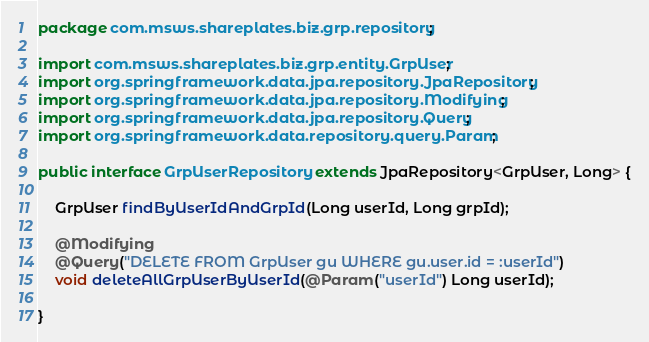<code> <loc_0><loc_0><loc_500><loc_500><_Java_>package com.msws.shareplates.biz.grp.repository;

import com.msws.shareplates.biz.grp.entity.GrpUser;
import org.springframework.data.jpa.repository.JpaRepository;
import org.springframework.data.jpa.repository.Modifying;
import org.springframework.data.jpa.repository.Query;
import org.springframework.data.repository.query.Param;

public interface GrpUserRepository extends JpaRepository<GrpUser, Long> {

    GrpUser findByUserIdAndGrpId(Long userId, Long grpId);

    @Modifying
    @Query("DELETE FROM GrpUser gu WHERE gu.user.id = :userId")
    void deleteAllGrpUserByUserId(@Param("userId") Long userId);

}

</code> 